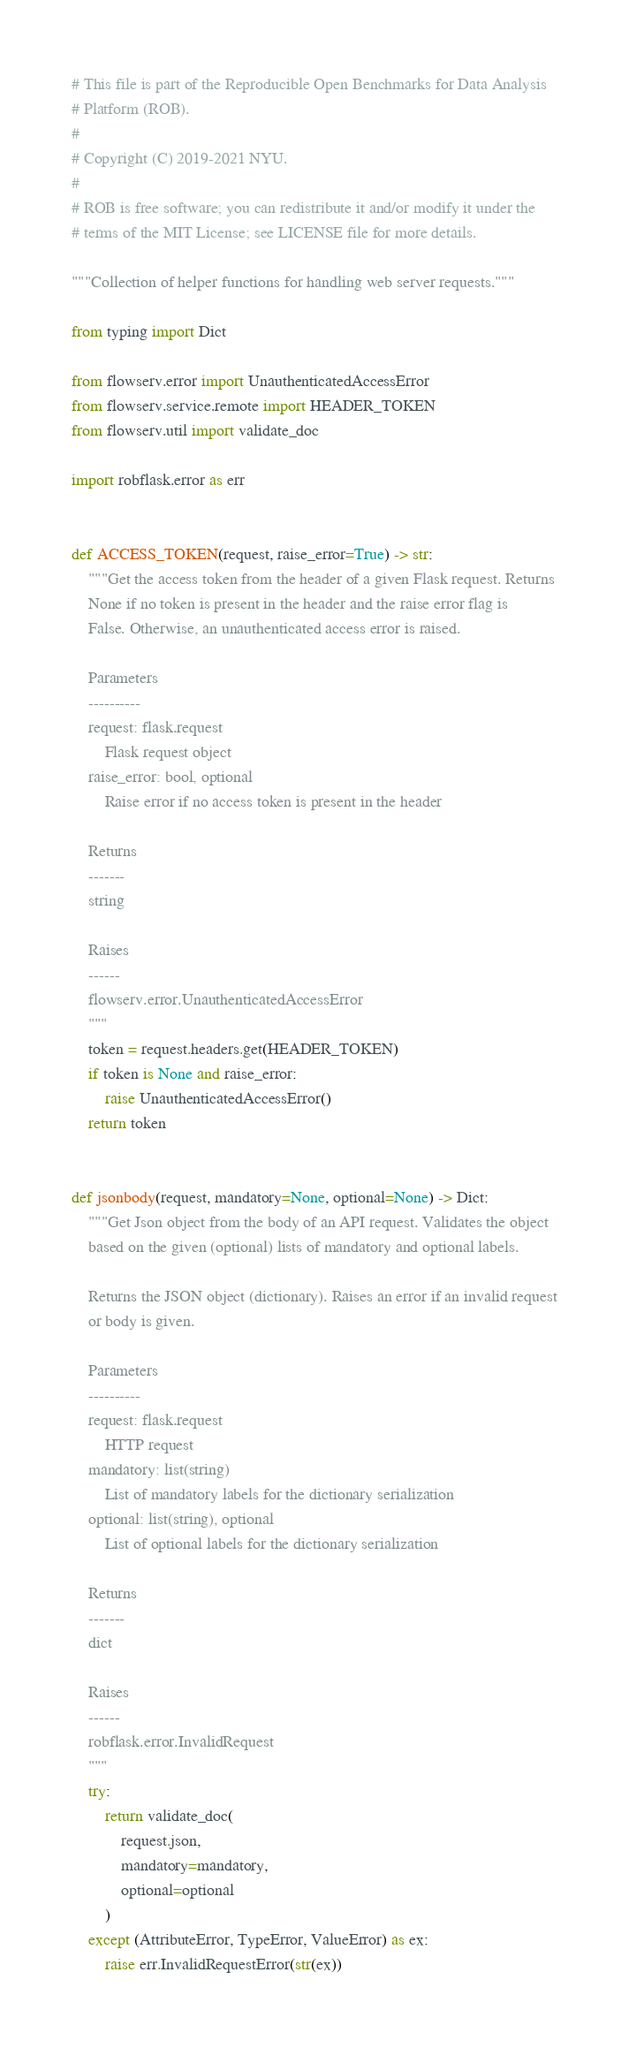Convert code to text. <code><loc_0><loc_0><loc_500><loc_500><_Python_># This file is part of the Reproducible Open Benchmarks for Data Analysis
# Platform (ROB).
#
# Copyright (C) 2019-2021 NYU.
#
# ROB is free software; you can redistribute it and/or modify it under the
# terms of the MIT License; see LICENSE file for more details.

"""Collection of helper functions for handling web server requests."""

from typing import Dict

from flowserv.error import UnauthenticatedAccessError
from flowserv.service.remote import HEADER_TOKEN
from flowserv.util import validate_doc

import robflask.error as err


def ACCESS_TOKEN(request, raise_error=True) -> str:
    """Get the access token from the header of a given Flask request. Returns
    None if no token is present in the header and the raise error flag is
    False. Otherwise, an unauthenticated access error is raised.

    Parameters
    ----------
    request: flask.request
        Flask request object
    raise_error: bool, optional
        Raise error if no access token is present in the header

    Returns
    -------
    string

    Raises
    ------
    flowserv.error.UnauthenticatedAccessError
    """
    token = request.headers.get(HEADER_TOKEN)
    if token is None and raise_error:
        raise UnauthenticatedAccessError()
    return token


def jsonbody(request, mandatory=None, optional=None) -> Dict:
    """Get Json object from the body of an API request. Validates the object
    based on the given (optional) lists of mandatory and optional labels.

    Returns the JSON object (dictionary). Raises an error if an invalid request
    or body is given.

    Parameters
    ----------
    request: flask.request
        HTTP request
    mandatory: list(string)
        List of mandatory labels for the dictionary serialization
    optional: list(string), optional
        List of optional labels for the dictionary serialization

    Returns
    -------
    dict

    Raises
    ------
    robflask.error.InvalidRequest
    """
    try:
        return validate_doc(
            request.json,
            mandatory=mandatory,
            optional=optional
        )
    except (AttributeError, TypeError, ValueError) as ex:
        raise err.InvalidRequestError(str(ex))
</code> 